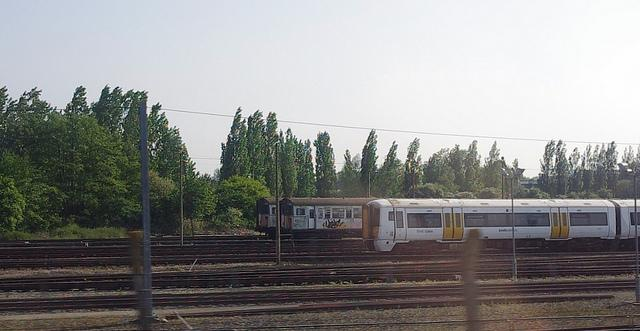During which time of the year are these trains operating? summer 